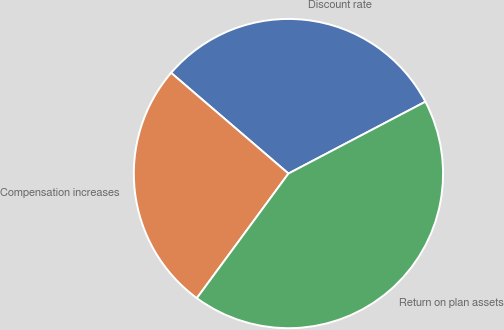Convert chart to OTSL. <chart><loc_0><loc_0><loc_500><loc_500><pie_chart><fcel>Discount rate<fcel>Compensation increases<fcel>Return on plan assets<nl><fcel>31.02%<fcel>26.2%<fcel>42.78%<nl></chart> 